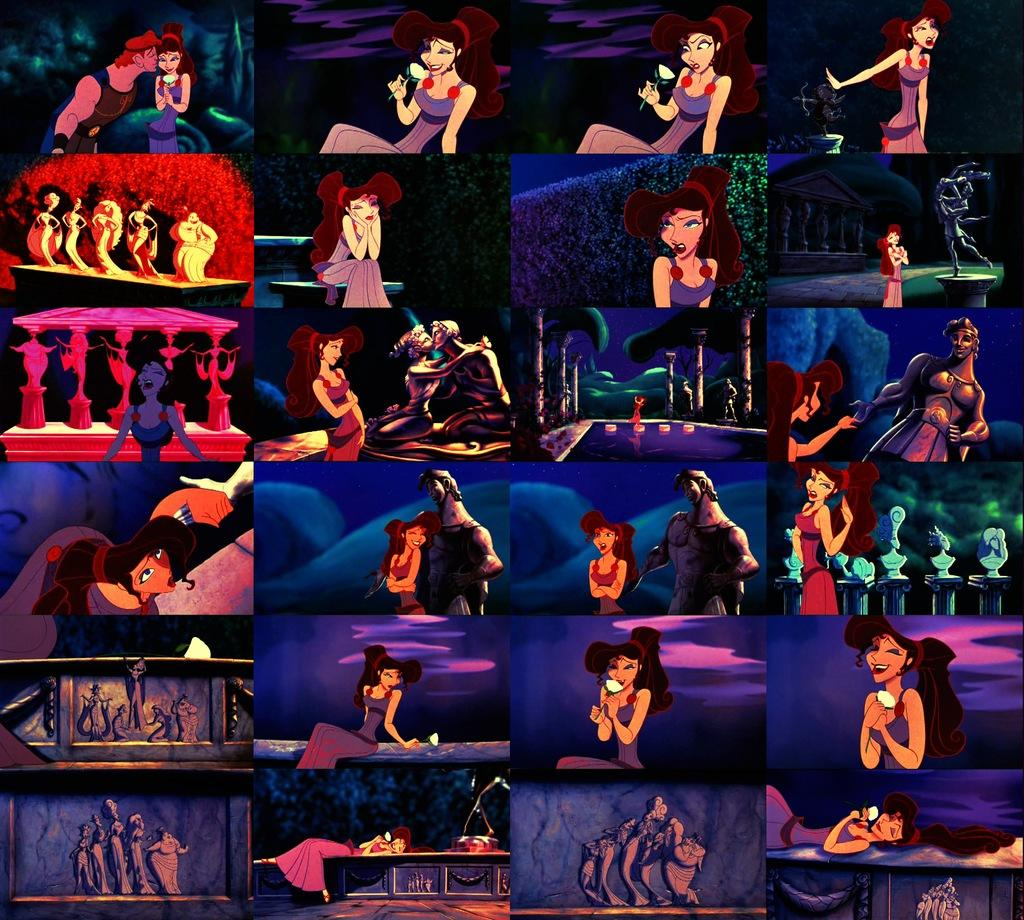What type of artwork is depicted in the image? There is a collage in the image. What kind of characters can be seen in the collage? There are cartoon characters in the collage. What other artistic elements are present in the collage? There are sculptures in the collage. Can you describe any other unspecified elements in the collage? There are other unspecified elements in the collage, but we cannot provide details without more information. How does the wrist of the cartoon character move in the image? There is no wrist movement depicted in the image, as it is a collage featuring static cartoon characters and sculptures. 